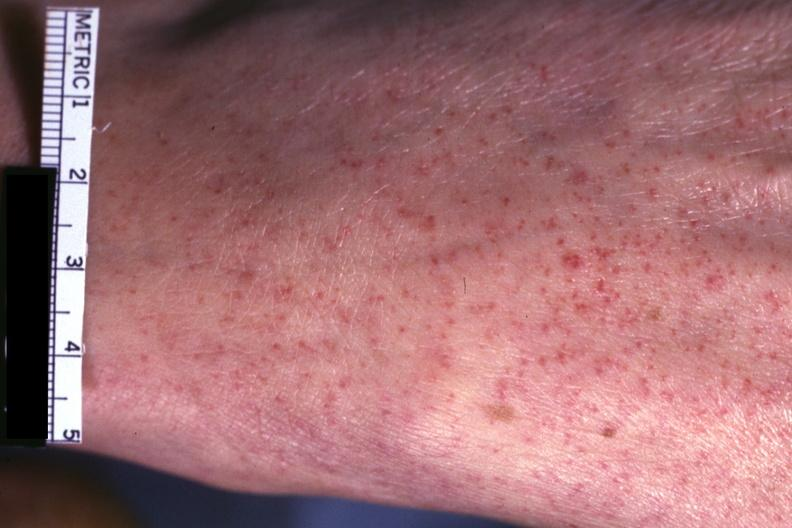what is present?
Answer the question using a single word or phrase. Petechiae 